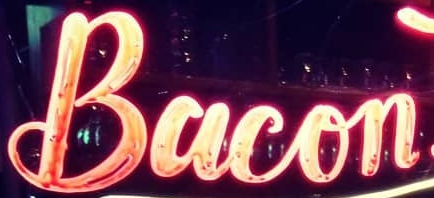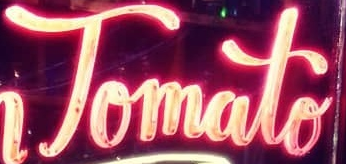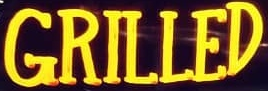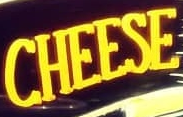Read the text from these images in sequence, separated by a semicolon. Bacon; Tomato; GRILLED; CHEESE 